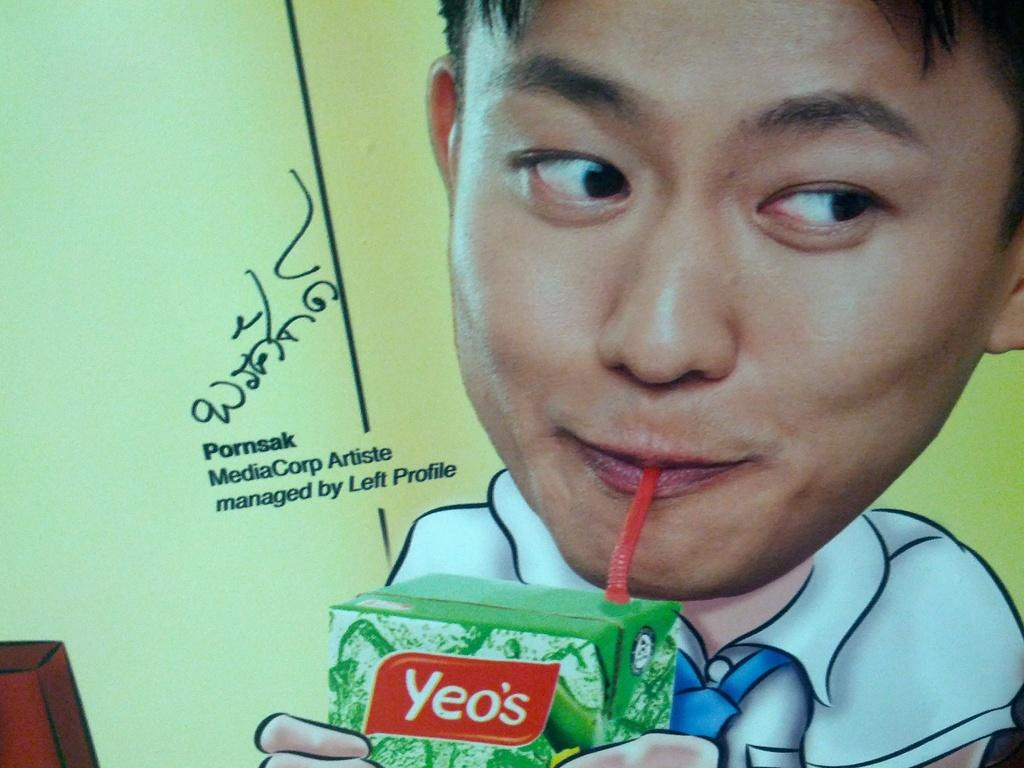What is the main subject of the poster in the image? The poster depicts a person holding a tetra pack. What is the person in the poster doing with the tetra pack? The person is drinking from the tetra pack using a straw. Is there any text on the poster? Yes, there is text on the poster. What is the purpose of the bun in the image? There is no bun present in the image. How does the poster show respect for the person holding the tetra pack? The poster does not explicitly show respect for the person holding the tetra pack; it simply depicts the person drinking from the tetra pack using a straw. 